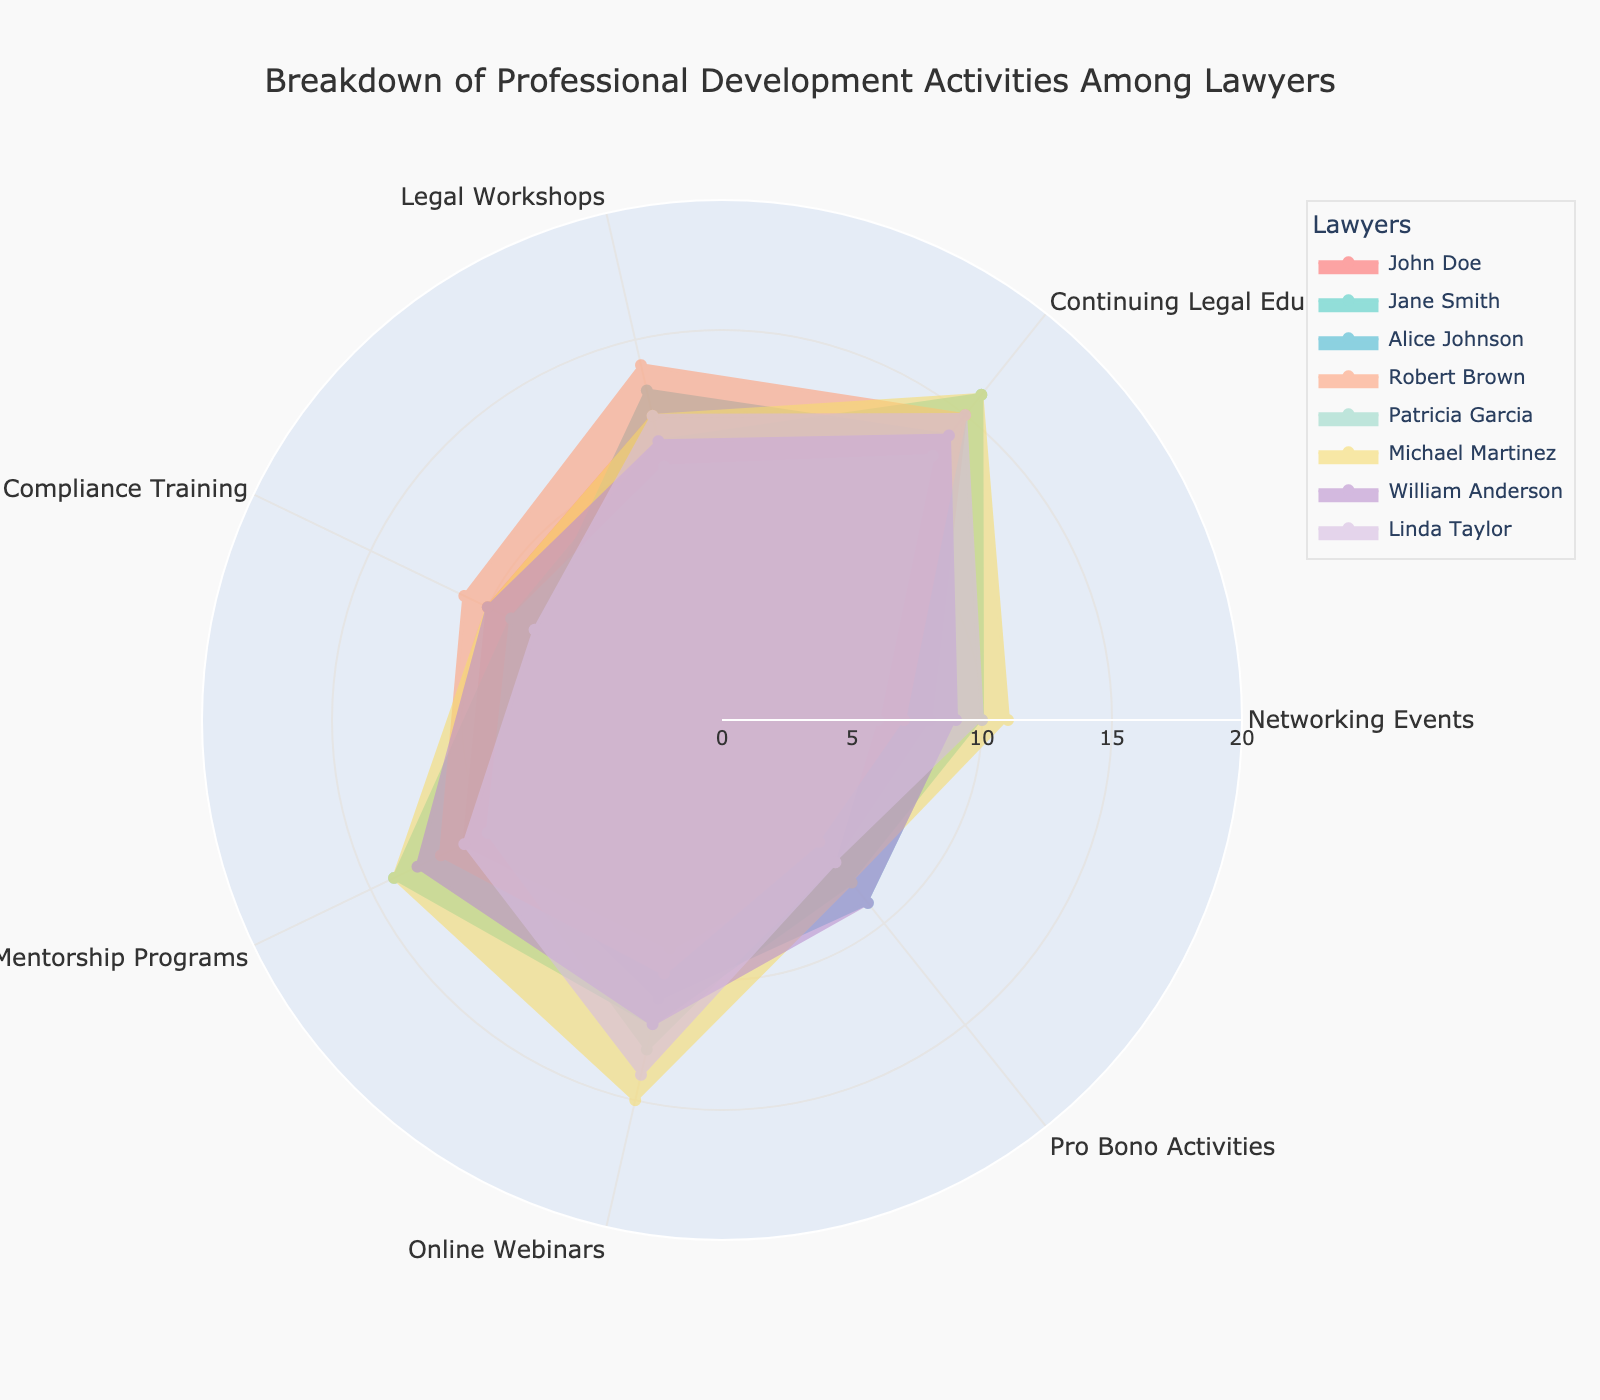What's the title of the radar chart? The title is usually found at the top of the chart and gives an overview of what the visual represents. In this case, it mentions the specific professional activities among lawyers.
Answer: Breakdown of Professional Development Activities Among Lawyers Which lawyer has the highest value in Online Webinars? Check each lawyer's value for Online Webinars and compare them to find the one with the highest number. Michael Martinez has the highest value with 15.
Answer: Michael Martinez How many categories are there in the radar chart? The categories can be determined by counting the distinct labels around the radar chart. These labels are Networking Events, Continuing Legal Education (CLE), Legal Workshops, Compliance Training, Mentorship Programs, Online Webinars, and Pro Bono Activities.
Answer: 7 What is the average value of CLE scores for all lawyers? List the CLE values for all lawyers: 15, 16, 14, 15, 13, 16, 14, 15. Sum them to get 118 and divide by 8 to get the average.
Answer: 14.75 Which categories have the same value for John Doe and Patricia Garcia? Compare the values for each category between John Doe and Patricia Garcia. Both have the same values for Networking Events (8) and Pro Bono Activities (7).
Answer: Networking Events, Pro Bono Activities Who has the smallest value in Networking Events and what's that value? Check the Networking Events values for all lawyers. Patricia Garcia has the smallest value which is 6.
Answer: Patricia Garcia, 6 Is there any category where all lawyers scored 10 or more? Check each lawyer's values for each category. Continuing Legal Education (CLE) and Compliance Training are the only categories where all lawyers have values 10 or greater.
Answer: CLE, Compliance Training Which lawyer has the lowest total score across all categories? Add up the values for each category for each lawyer. Patricia Garcia has the lowest total score of 68.
Answer: Patricia Garcia What is the sum of values for Legal Workshops for Jane Smith and Robert Brown? Sum Jane Smith's 11 and Robert Brown's 14 to get the total value for Legal Workshops for both.
Answer: 25 Who participates more actively in Pro Bono Activities, John Doe or William Anderson? Compare the values for Pro Bono Activities. John Doe has a value of 7, while William Anderson also has 9.
Answer: William Anderson 